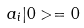Convert formula to latex. <formula><loc_0><loc_0><loc_500><loc_500>a _ { i } | 0 > = 0</formula> 